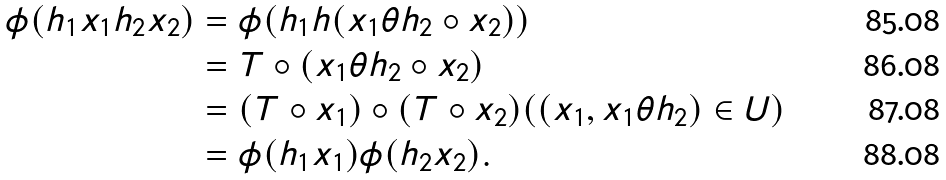<formula> <loc_0><loc_0><loc_500><loc_500>\phi ( h _ { 1 } x _ { 1 } h _ { 2 } x _ { 2 } ) & = \phi ( h _ { 1 } h ( x _ { 1 } { \theta } h _ { 2 } \circ x _ { 2 } ) ) \\ & = T \circ ( x _ { 1 } { \theta } h _ { 2 } \circ x _ { 2 } ) \\ & = ( T \circ x _ { 1 } ) \circ ( T \circ x _ { 2 } ) ( ( x _ { 1 } , x _ { 1 } { \theta } h _ { 2 } ) \in U ) \\ & = \phi ( h _ { 1 } x _ { 1 } ) \phi ( h _ { 2 } x _ { 2 } ) .</formula> 